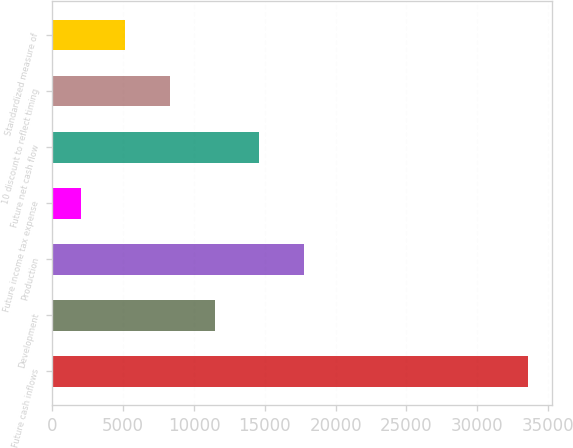Convert chart. <chart><loc_0><loc_0><loc_500><loc_500><bar_chart><fcel>Future cash inflows<fcel>Development<fcel>Production<fcel>Future income tax expense<fcel>Future net cash flow<fcel>10 discount to reflect timing<fcel>Standardized measure of<nl><fcel>33570<fcel>11465.4<fcel>17781<fcel>1992<fcel>14623.2<fcel>8307.6<fcel>5149.8<nl></chart> 